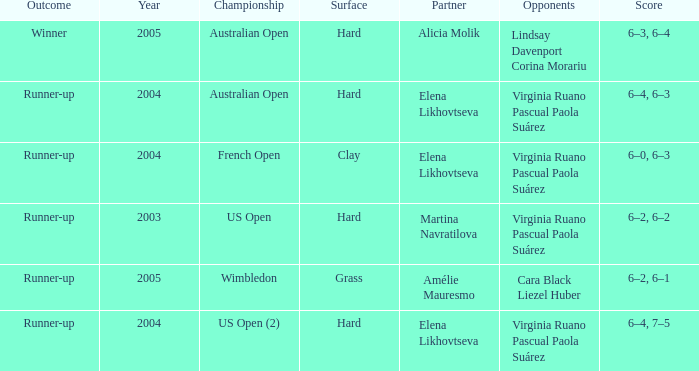When winner is the outcome what is the score? 6–3, 6–4. 